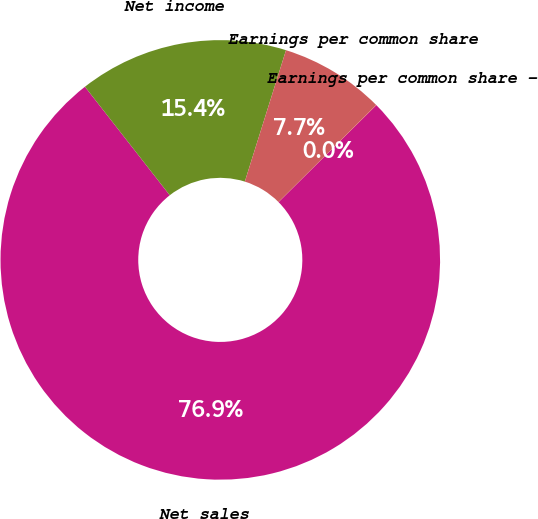<chart> <loc_0><loc_0><loc_500><loc_500><pie_chart><fcel>Net sales<fcel>Net income<fcel>Earnings per common share<fcel>Earnings per common share -<nl><fcel>76.87%<fcel>15.39%<fcel>7.71%<fcel>0.02%<nl></chart> 